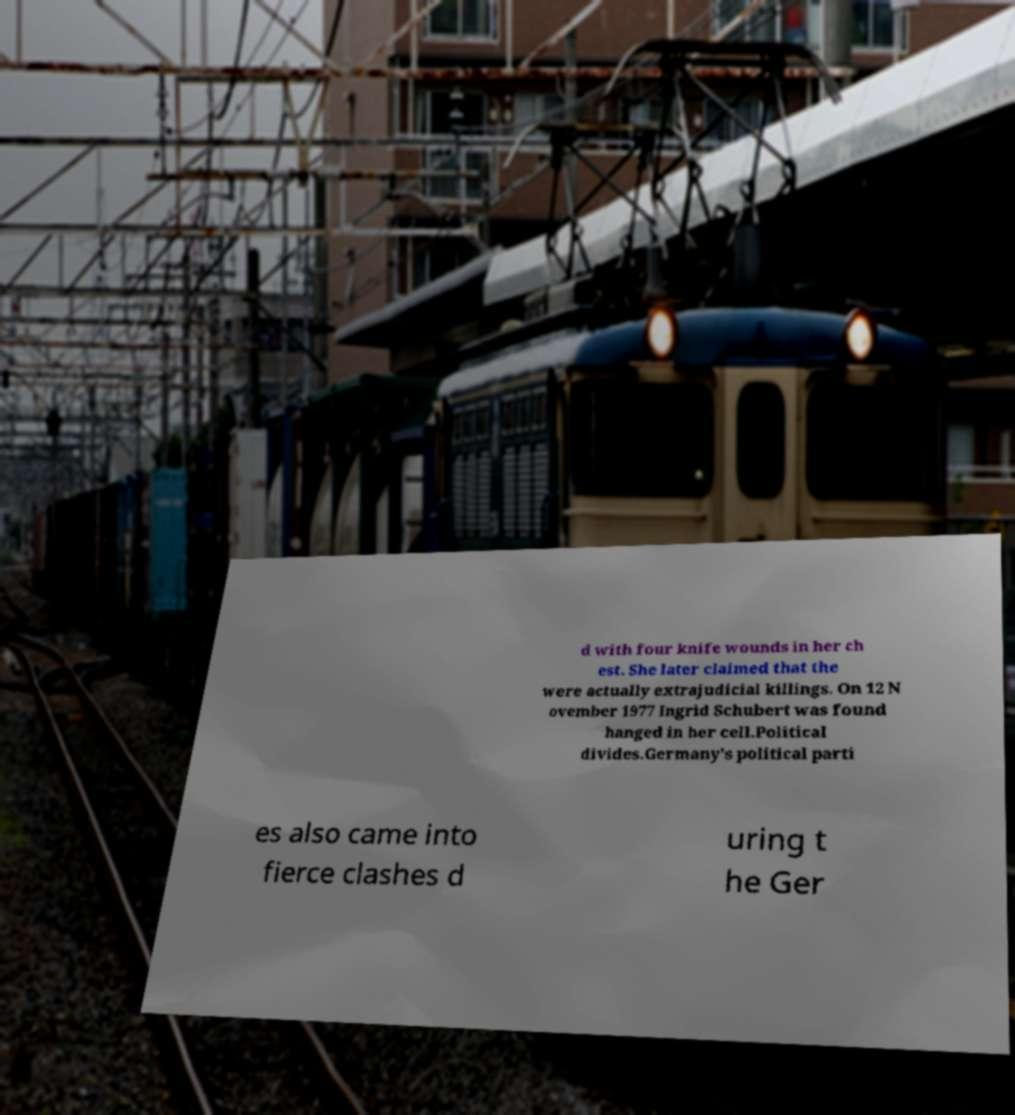For documentation purposes, I need the text within this image transcribed. Could you provide that? d with four knife wounds in her ch est. She later claimed that the were actually extrajudicial killings. On 12 N ovember 1977 Ingrid Schubert was found hanged in her cell.Political divides.Germany's political parti es also came into fierce clashes d uring t he Ger 